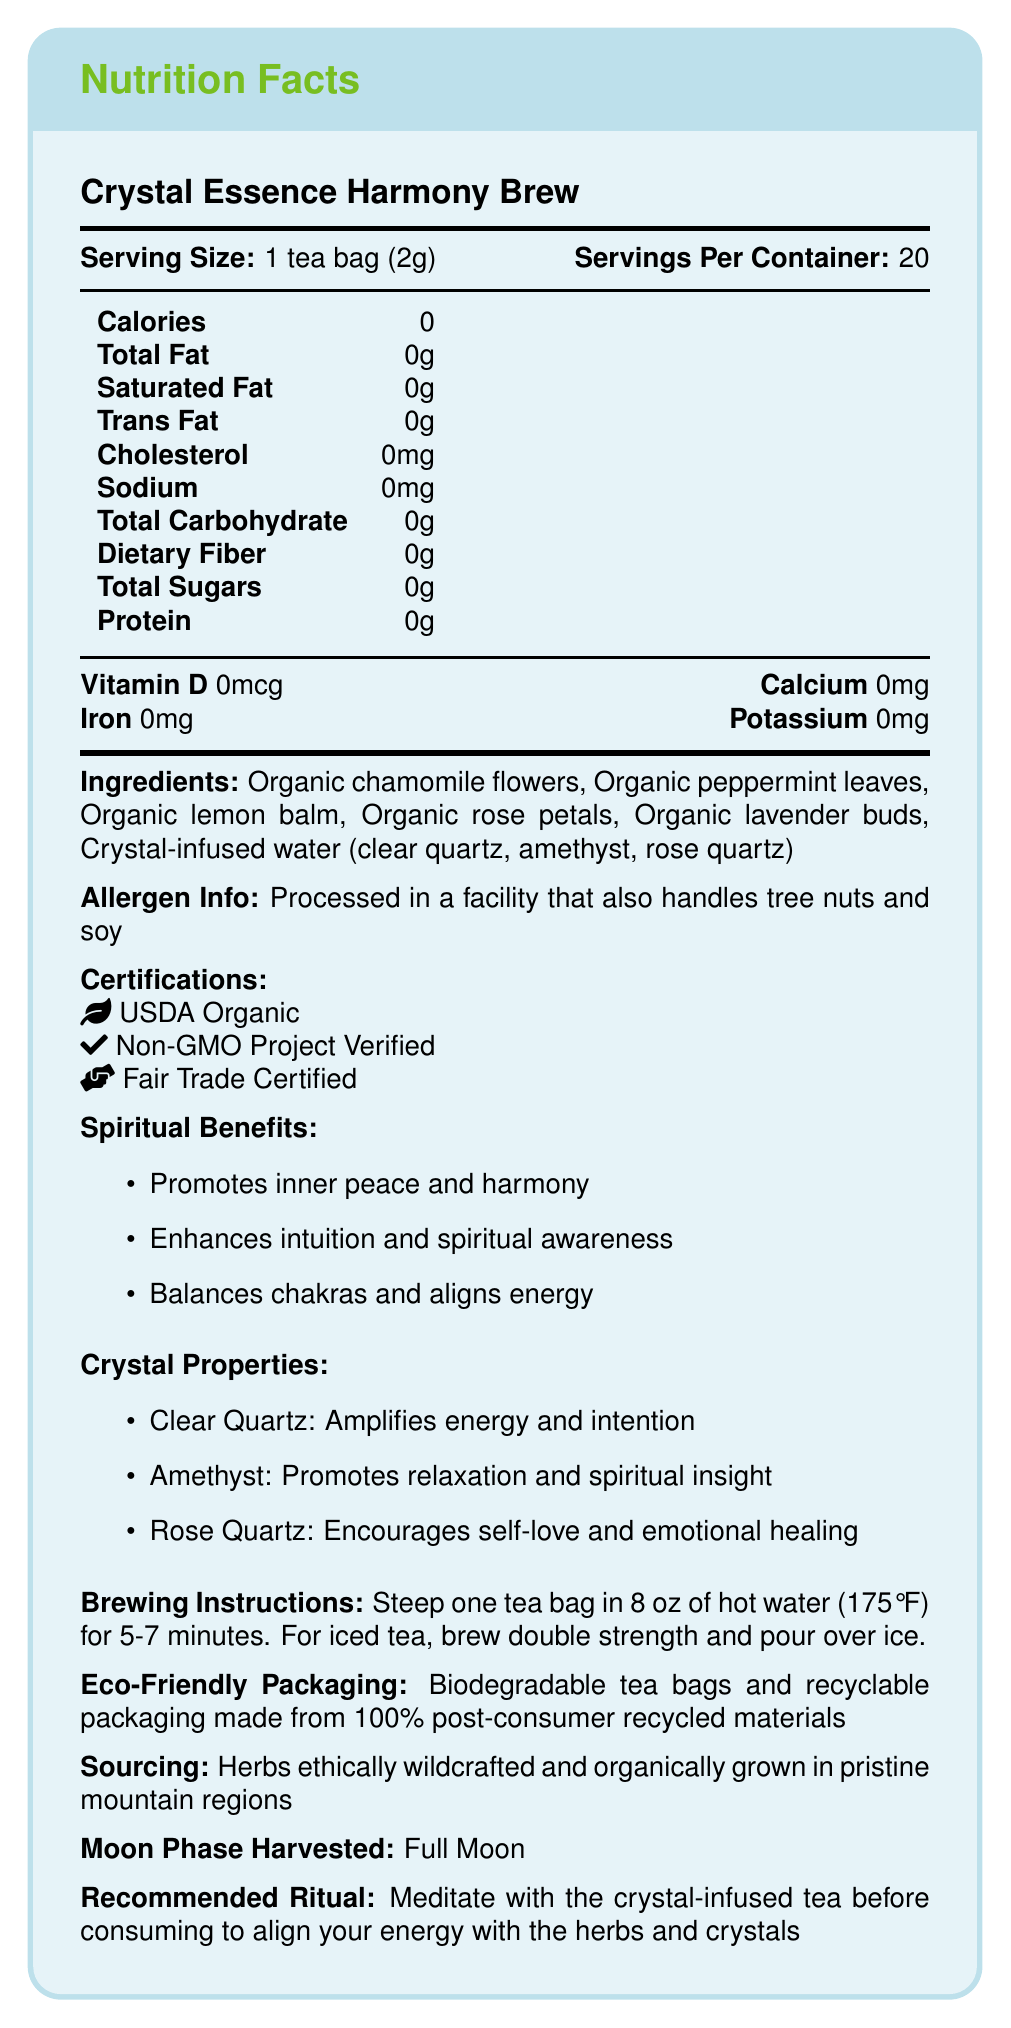what is the serving size for Crystal Essence Harmony Brew? The document states under the nutrition facts that the serving size is 1 tea bag (2g).
Answer: 1 tea bag (2g) how many servings are in each container? The document specifies that there are 20 servings per container.
Answer: 20 how many calories are in one serving? According to the nutrition facts, one serving contains 0 calories.
Answer: 0 calories does this product contain any sugars? The nutrition facts indicate that the total sugars per serving are 0g.
Answer: No is this product vegan? The ingredients listed are all plant-based, and there is no mention of animal products.
Answer: Yes which crystals are infused in the water used for this tea? A. Clear Quartz, Amethyst B. Clear Quartz, Amethyst, Rose Quartz C. Rose Quartz, Sodalite, Citrine D. Clear Quartz, Garnet, Rose Quartz The document mentions that the crystal-infused water contains clear quartz, amethyst, and rose quartz.
Answer: B. Clear Quartz, Amethyst, Rose Quartz what certification ensures this product is not genetically modified? A. USDA Organic B. Fair Trade Certified C. Non-GMO Project Verified D. Vegan Certified The certifications list includes "Non-GMO Project Verified."
Answer: C. Non-GMO Project Verified is the packaging environmentally friendly? The document states that the packaging is biodegradable and made from 100% post-consumer recycled materials.
Answer: Yes summarize the key points about Crystal Essence Harmony Brew. The product is a spiritually beneficial, vegan, zero-calorie tea blend with various organic ingredients and certifications, using crystal-infused water for added energetic properties. It has eco-friendly packaging and promotes a ritual for spiritual alignment.
Answer: Crystal Essence Harmony Brew is a vegan, organic herbal tea blend infused with crystal-charged water, offering zero calories per serving. It contains organic chamomile flowers, peppermint leaves, lemon balm, rose petals, and lavender buds. The tea promotes spiritual benefits such as inner peace and chakra balancing. It is USDA Organic, Non-GMO Project Verified, and Fair Trade Certified with eco-friendly packaging. how many benefits are mentioned under "Spiritual Benefits"? The Spiritual Benefits section lists three benefits: promoting inner peace and harmony, enhancing intuition and spiritual awareness, and balancing chakras and aligning energy.
Answer: 3 does the Crystal Essence Harmony Brew contain any fat? The document states that there is 0g total fat per serving.
Answer: No which moon phase was this product harvested in? The document mentions the herbs were harvested during the Full Moon.
Answer: Full Moon what are the properties of clear quartz as listed in the document? The Crystal Properties section states that clear quartz amplifies energy and intention.
Answer: Amplifies energy and intention what type of facility processes this tea? The Allergen Info section specifies that the tea is processed in a facility that also handles tree nuts and soy.
Answer: A facility that also handles tree nuts and soy what is the recommended process before consuming the tea? A. Boil the tea for 10 minutes B. Cool the tea in the refrigerator C. Meditate with the crystal-infused tea D. Add honey The Recommended Ritual section advises meditation with the crystal-infused tea before consuming to align energy with the herbs and crystals.
Answer: C. Meditate with the crystal-infused tea which ingredient is not included in the Crystal Essence Harmony Brew? A. Lavender Buds B. Hibiscus Flowers C. Lemon Balm D. Rose Petals The ingredients list does not mention Hibiscus Flowers but includes Lavender Buds, Lemon Balm, and Rose Petals.
Answer: B. Hibiscus Flowers what are the primary benefits of amethyst as per the document? According to the Crystal Properties section, amethyst promotes relaxation and spiritual insight.
Answer: Promotes relaxation and spiritual insight are there any dietary fibers in this tea blend? The nutrition facts state that the dietary fiber content is 0g per serving.
Answer: No who is the manufacturer of the Crystal Essence Harmony Brew? The document does not provide information on the manufacturer of the tea.
Answer: Not enough information 